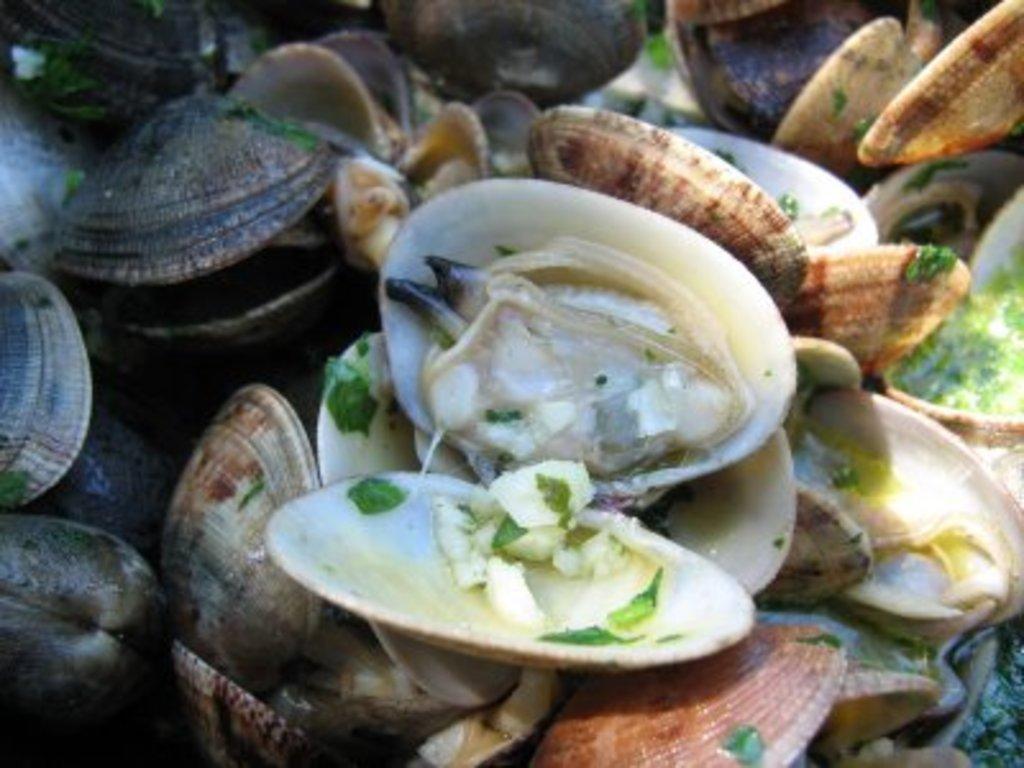Could you give a brief overview of what you see in this image? In this picture we can see a group of shells in different colors. 